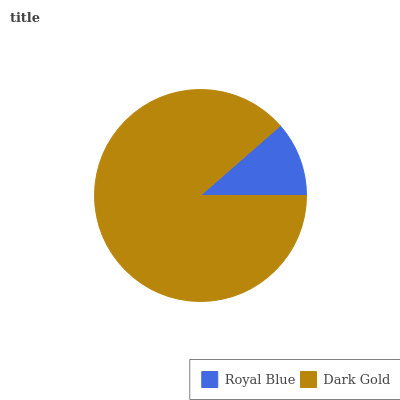Is Royal Blue the minimum?
Answer yes or no. Yes. Is Dark Gold the maximum?
Answer yes or no. Yes. Is Dark Gold the minimum?
Answer yes or no. No. Is Dark Gold greater than Royal Blue?
Answer yes or no. Yes. Is Royal Blue less than Dark Gold?
Answer yes or no. Yes. Is Royal Blue greater than Dark Gold?
Answer yes or no. No. Is Dark Gold less than Royal Blue?
Answer yes or no. No. Is Dark Gold the high median?
Answer yes or no. Yes. Is Royal Blue the low median?
Answer yes or no. Yes. Is Royal Blue the high median?
Answer yes or no. No. Is Dark Gold the low median?
Answer yes or no. No. 